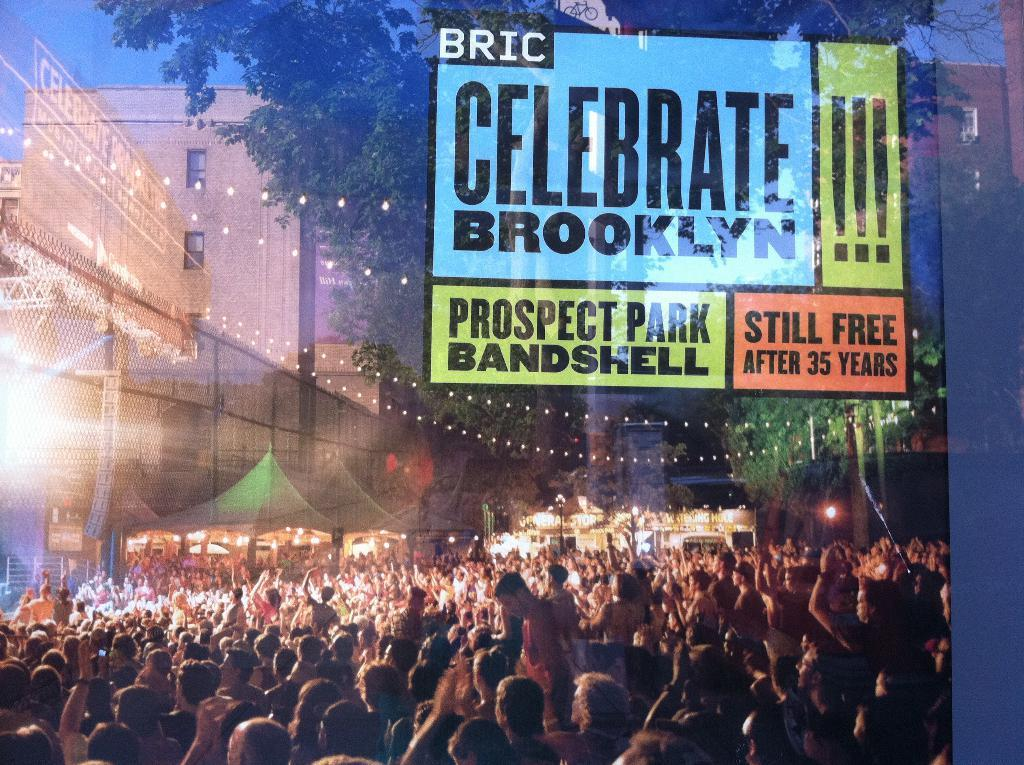<image>
Present a compact description of the photo's key features. A group of people that are out celebrating brooklyn one afternoon. 